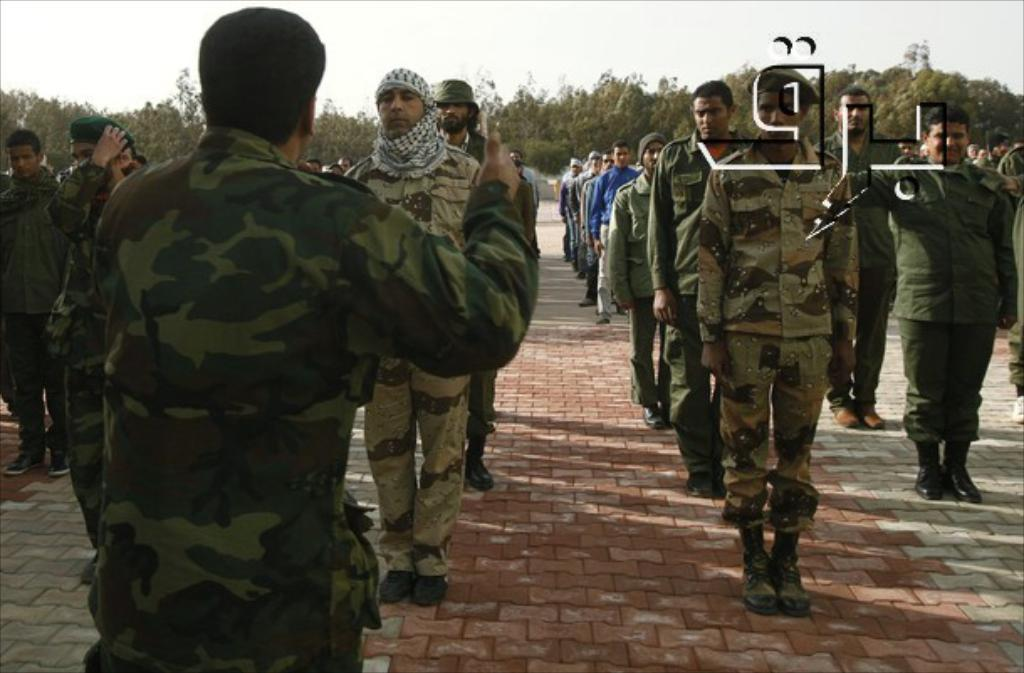How many people are in the image? There is a group of people in the image, but the exact number is not specified. What type of footwear are the people wearing? The people in the image are wearing shoes. What type of headwear is visible on some of the people? Some of the people are wearing caps. What surface are the people standing on? The people are standing on the ground. What can be seen in the background of the image? There are trees and the sky visible in the background of the image. Reasoning: Let' Let's think step by step in order to produce the conversation. We start by acknowledging the presence of a group of people in the image. Then, we describe specific details about the people, such as their footwear and headwear. Next, we mention the surface they are standing on and the background elements visible in the image. Each question is designed to elicit a specific detail about the image that can be answered definitively with the information given. Absurd Question/Answer: What type of cream is being used to support the authority of the trees in the image? There is no cream or mention of authority in the image; it simply shows a group of people standing on the ground with trees and the sky in the background. 